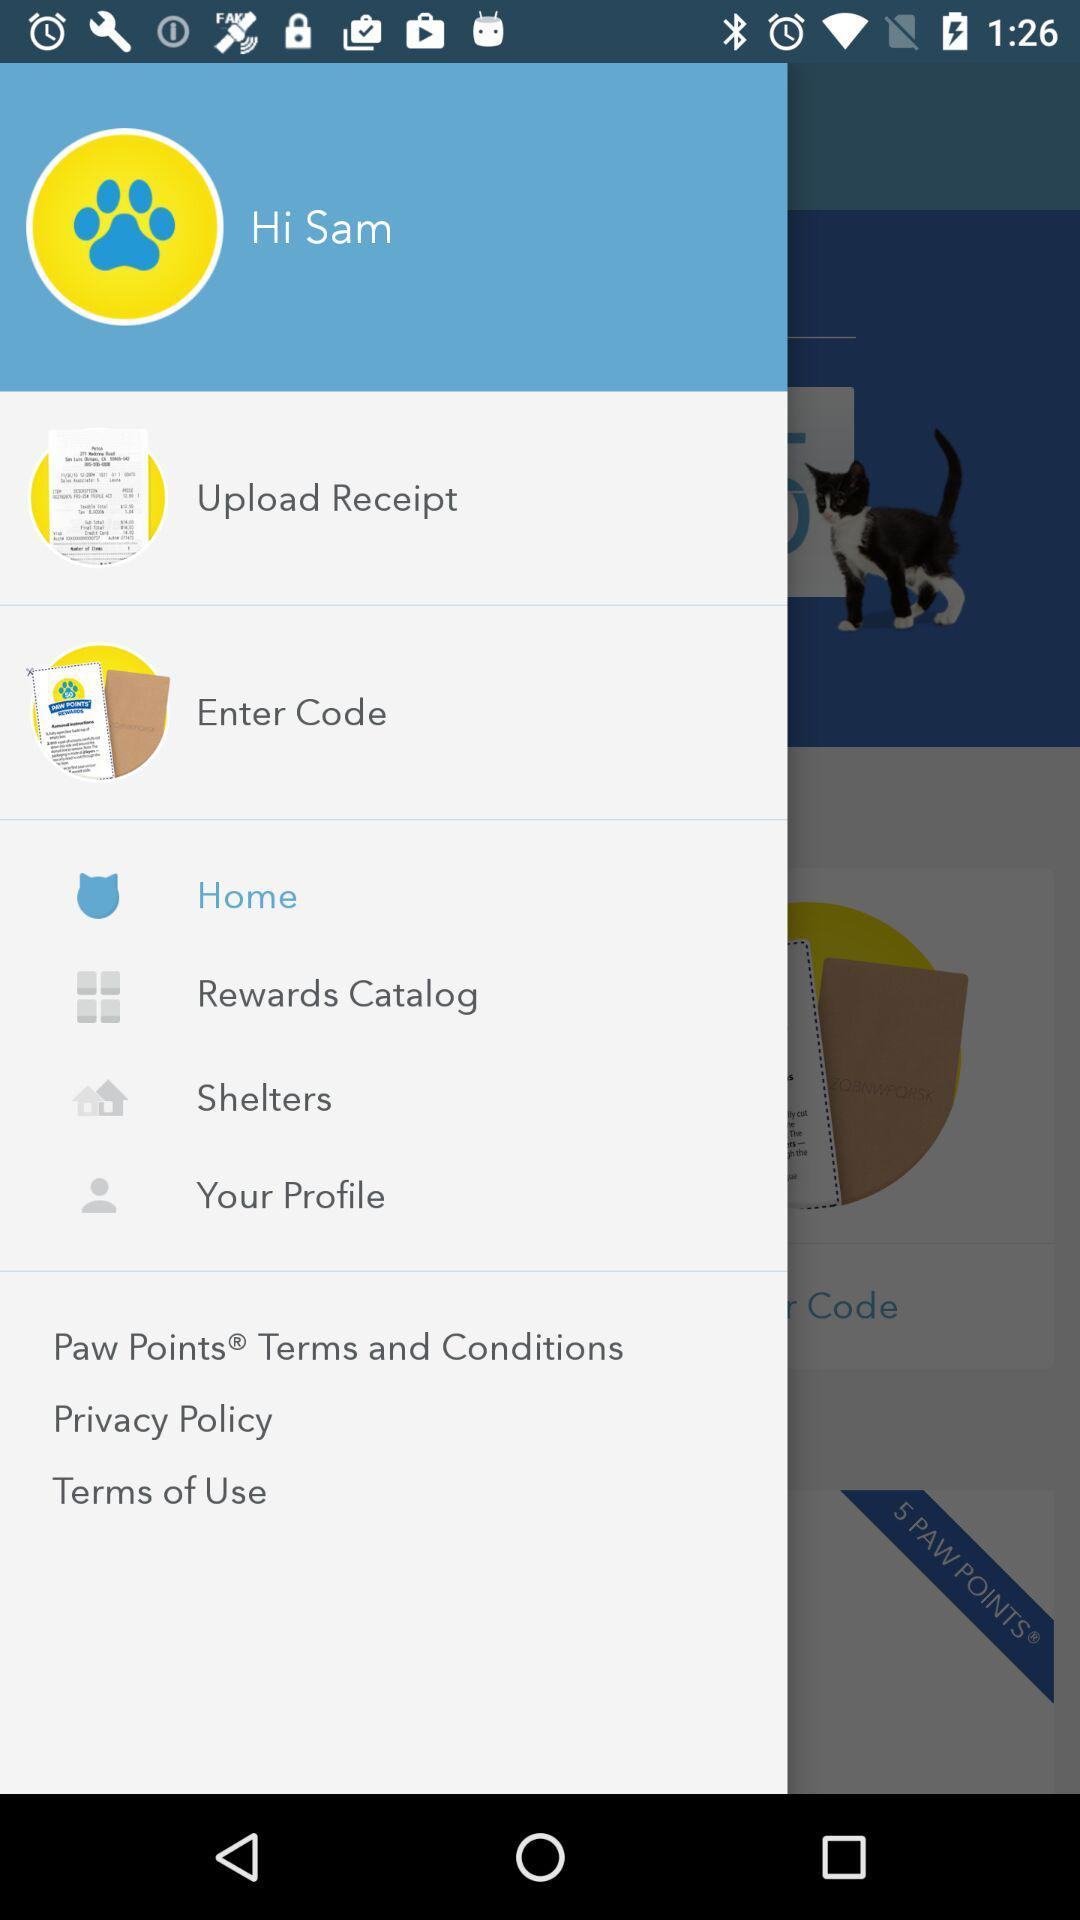What is the name of the user? The name of the user is Sam. 